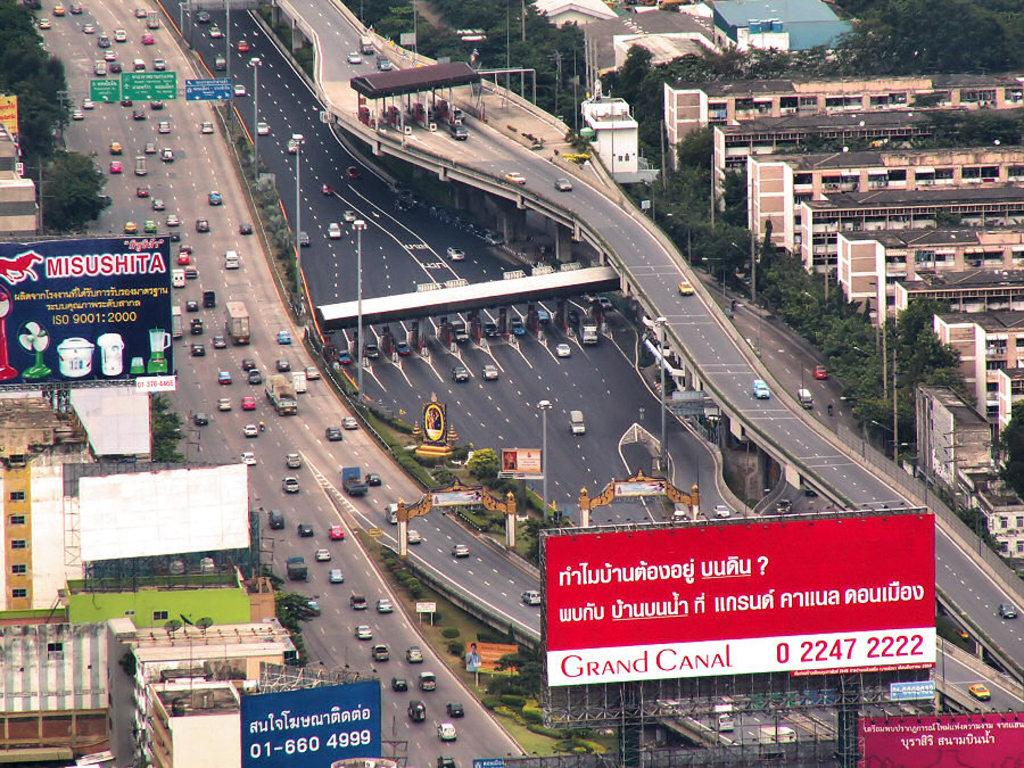<image>
Give a short and clear explanation of the subsequent image. A busy highway surrounded by billboards for Misushita, Grand Canal, and other businesses. 